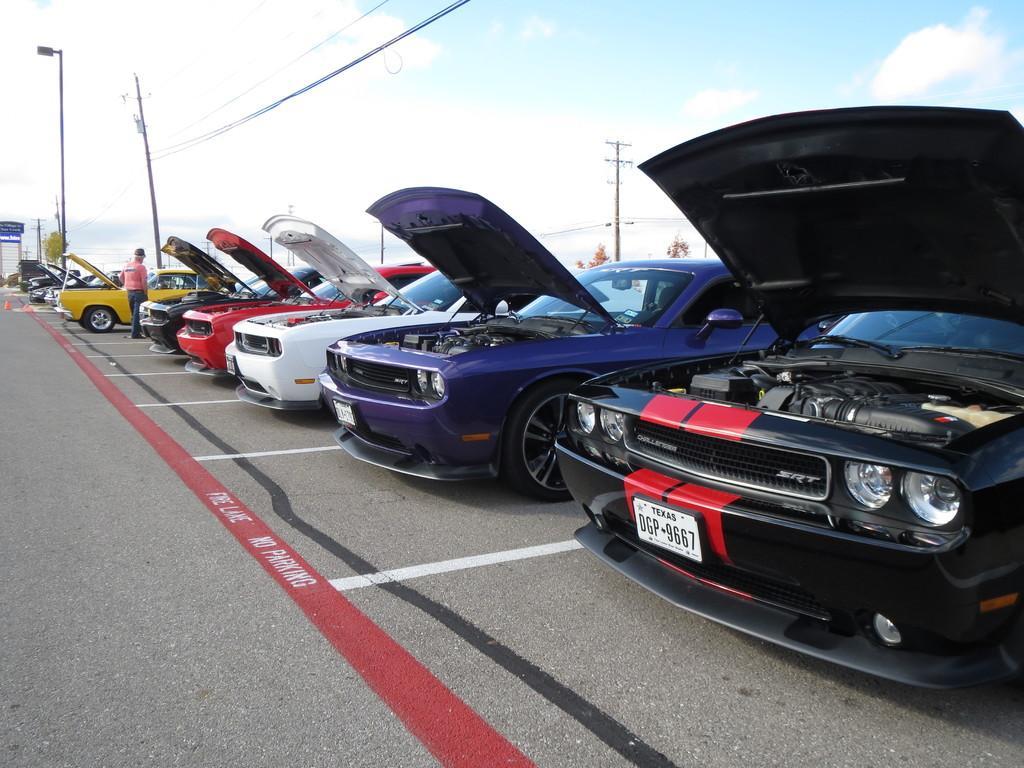Describe this image in one or two sentences. In this image we can see some cars on the road, some text on the road, some number plates attached to the cars, few objects on the road, one board with text, one object on the left side of the image, some trees in the background, some poles with wires, some objects attached to the poles, one man standing near the car and at the top there is the sky. 